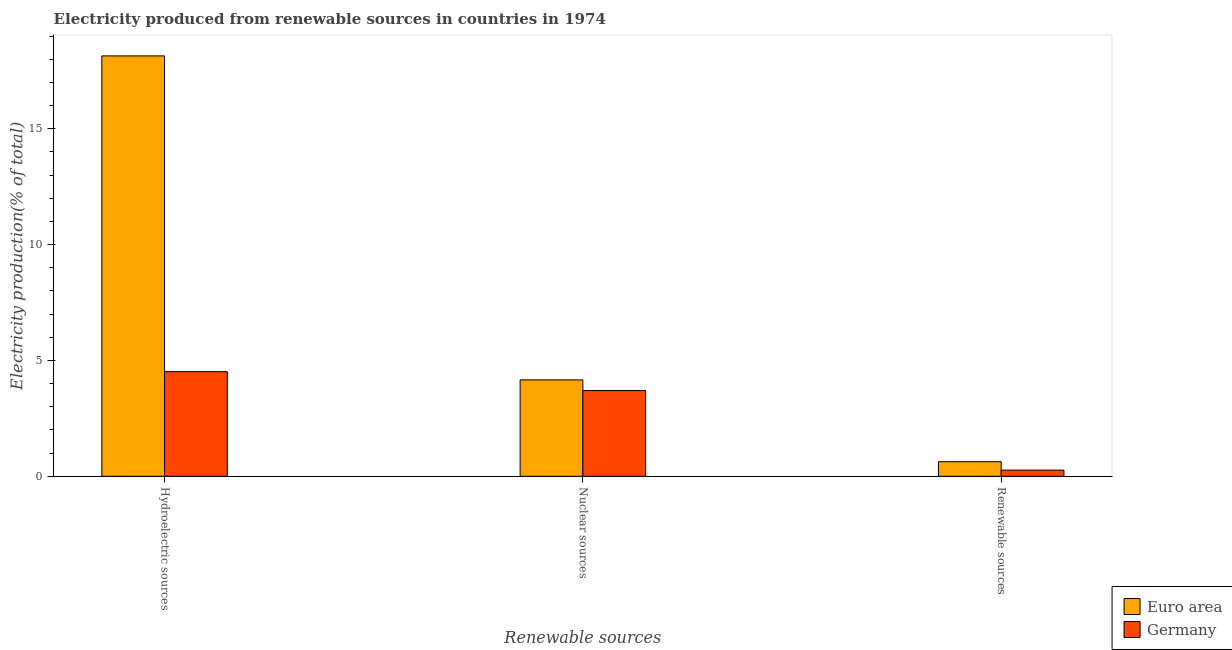Are the number of bars per tick equal to the number of legend labels?
Make the answer very short. Yes. How many bars are there on the 2nd tick from the right?
Your response must be concise. 2. What is the label of the 1st group of bars from the left?
Make the answer very short. Hydroelectric sources. What is the percentage of electricity produced by hydroelectric sources in Germany?
Provide a short and direct response. 4.52. Across all countries, what is the maximum percentage of electricity produced by renewable sources?
Keep it short and to the point. 0.63. Across all countries, what is the minimum percentage of electricity produced by hydroelectric sources?
Make the answer very short. 4.52. In which country was the percentage of electricity produced by hydroelectric sources minimum?
Your answer should be very brief. Germany. What is the total percentage of electricity produced by renewable sources in the graph?
Offer a very short reply. 0.9. What is the difference between the percentage of electricity produced by nuclear sources in Euro area and that in Germany?
Your answer should be compact. 0.46. What is the difference between the percentage of electricity produced by renewable sources in Germany and the percentage of electricity produced by nuclear sources in Euro area?
Offer a very short reply. -3.89. What is the average percentage of electricity produced by renewable sources per country?
Offer a terse response. 0.45. What is the difference between the percentage of electricity produced by renewable sources and percentage of electricity produced by hydroelectric sources in Euro area?
Your response must be concise. -17.51. What is the ratio of the percentage of electricity produced by hydroelectric sources in Euro area to that in Germany?
Offer a terse response. 4.02. What is the difference between the highest and the second highest percentage of electricity produced by hydroelectric sources?
Offer a terse response. 13.62. What is the difference between the highest and the lowest percentage of electricity produced by hydroelectric sources?
Keep it short and to the point. 13.62. In how many countries, is the percentage of electricity produced by nuclear sources greater than the average percentage of electricity produced by nuclear sources taken over all countries?
Keep it short and to the point. 1. What does the 2nd bar from the left in Renewable sources represents?
Offer a terse response. Germany. What does the 1st bar from the right in Nuclear sources represents?
Your answer should be very brief. Germany. How many bars are there?
Offer a very short reply. 6. Are all the bars in the graph horizontal?
Provide a short and direct response. No. How many countries are there in the graph?
Your answer should be compact. 2. Where does the legend appear in the graph?
Offer a terse response. Bottom right. How many legend labels are there?
Keep it short and to the point. 2. How are the legend labels stacked?
Your answer should be compact. Vertical. What is the title of the graph?
Your answer should be compact. Electricity produced from renewable sources in countries in 1974. What is the label or title of the X-axis?
Provide a succinct answer. Renewable sources. What is the label or title of the Y-axis?
Offer a terse response. Electricity production(% of total). What is the Electricity production(% of total) of Euro area in Hydroelectric sources?
Provide a short and direct response. 18.14. What is the Electricity production(% of total) of Germany in Hydroelectric sources?
Provide a short and direct response. 4.52. What is the Electricity production(% of total) in Euro area in Nuclear sources?
Your answer should be compact. 4.16. What is the Electricity production(% of total) in Germany in Nuclear sources?
Offer a terse response. 3.7. What is the Electricity production(% of total) of Euro area in Renewable sources?
Give a very brief answer. 0.63. What is the Electricity production(% of total) of Germany in Renewable sources?
Give a very brief answer. 0.27. Across all Renewable sources, what is the maximum Electricity production(% of total) in Euro area?
Your response must be concise. 18.14. Across all Renewable sources, what is the maximum Electricity production(% of total) in Germany?
Offer a very short reply. 4.52. Across all Renewable sources, what is the minimum Electricity production(% of total) in Euro area?
Keep it short and to the point. 0.63. Across all Renewable sources, what is the minimum Electricity production(% of total) in Germany?
Ensure brevity in your answer.  0.27. What is the total Electricity production(% of total) of Euro area in the graph?
Provide a succinct answer. 22.93. What is the total Electricity production(% of total) of Germany in the graph?
Provide a short and direct response. 8.49. What is the difference between the Electricity production(% of total) in Euro area in Hydroelectric sources and that in Nuclear sources?
Offer a terse response. 13.98. What is the difference between the Electricity production(% of total) in Germany in Hydroelectric sources and that in Nuclear sources?
Ensure brevity in your answer.  0.81. What is the difference between the Electricity production(% of total) in Euro area in Hydroelectric sources and that in Renewable sources?
Offer a terse response. 17.51. What is the difference between the Electricity production(% of total) in Germany in Hydroelectric sources and that in Renewable sources?
Make the answer very short. 4.25. What is the difference between the Electricity production(% of total) of Euro area in Nuclear sources and that in Renewable sources?
Provide a short and direct response. 3.53. What is the difference between the Electricity production(% of total) in Germany in Nuclear sources and that in Renewable sources?
Your answer should be compact. 3.43. What is the difference between the Electricity production(% of total) in Euro area in Hydroelectric sources and the Electricity production(% of total) in Germany in Nuclear sources?
Your response must be concise. 14.44. What is the difference between the Electricity production(% of total) in Euro area in Hydroelectric sources and the Electricity production(% of total) in Germany in Renewable sources?
Your response must be concise. 17.87. What is the difference between the Electricity production(% of total) in Euro area in Nuclear sources and the Electricity production(% of total) in Germany in Renewable sources?
Make the answer very short. 3.89. What is the average Electricity production(% of total) in Euro area per Renewable sources?
Provide a short and direct response. 7.64. What is the average Electricity production(% of total) in Germany per Renewable sources?
Your answer should be very brief. 2.83. What is the difference between the Electricity production(% of total) of Euro area and Electricity production(% of total) of Germany in Hydroelectric sources?
Offer a very short reply. 13.62. What is the difference between the Electricity production(% of total) in Euro area and Electricity production(% of total) in Germany in Nuclear sources?
Make the answer very short. 0.46. What is the difference between the Electricity production(% of total) of Euro area and Electricity production(% of total) of Germany in Renewable sources?
Provide a short and direct response. 0.36. What is the ratio of the Electricity production(% of total) of Euro area in Hydroelectric sources to that in Nuclear sources?
Your answer should be compact. 4.36. What is the ratio of the Electricity production(% of total) of Germany in Hydroelectric sources to that in Nuclear sources?
Ensure brevity in your answer.  1.22. What is the ratio of the Electricity production(% of total) in Euro area in Hydroelectric sources to that in Renewable sources?
Provide a short and direct response. 28.78. What is the ratio of the Electricity production(% of total) of Germany in Hydroelectric sources to that in Renewable sources?
Your answer should be compact. 16.86. What is the ratio of the Electricity production(% of total) in Euro area in Nuclear sources to that in Renewable sources?
Offer a very short reply. 6.6. What is the ratio of the Electricity production(% of total) of Germany in Nuclear sources to that in Renewable sources?
Keep it short and to the point. 13.82. What is the difference between the highest and the second highest Electricity production(% of total) in Euro area?
Ensure brevity in your answer.  13.98. What is the difference between the highest and the second highest Electricity production(% of total) of Germany?
Provide a short and direct response. 0.81. What is the difference between the highest and the lowest Electricity production(% of total) of Euro area?
Ensure brevity in your answer.  17.51. What is the difference between the highest and the lowest Electricity production(% of total) of Germany?
Give a very brief answer. 4.25. 